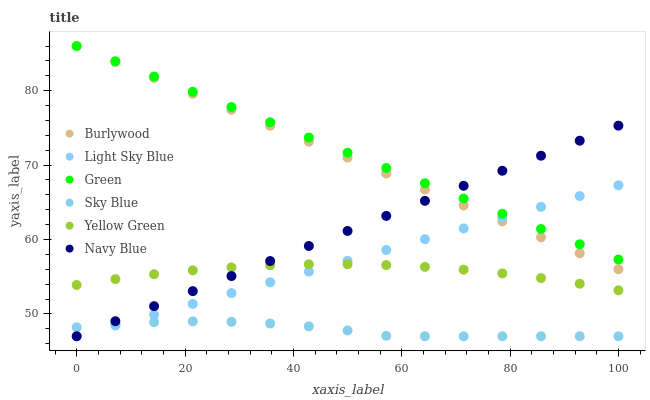Does Sky Blue have the minimum area under the curve?
Answer yes or no. Yes. Does Green have the maximum area under the curve?
Answer yes or no. Yes. Does Burlywood have the minimum area under the curve?
Answer yes or no. No. Does Burlywood have the maximum area under the curve?
Answer yes or no. No. Is Navy Blue the smoothest?
Answer yes or no. Yes. Is Sky Blue the roughest?
Answer yes or no. Yes. Is Burlywood the smoothest?
Answer yes or no. No. Is Burlywood the roughest?
Answer yes or no. No. Does Navy Blue have the lowest value?
Answer yes or no. Yes. Does Burlywood have the lowest value?
Answer yes or no. No. Does Green have the highest value?
Answer yes or no. Yes. Does Navy Blue have the highest value?
Answer yes or no. No. Is Sky Blue less than Green?
Answer yes or no. Yes. Is Burlywood greater than Sky Blue?
Answer yes or no. Yes. Does Light Sky Blue intersect Green?
Answer yes or no. Yes. Is Light Sky Blue less than Green?
Answer yes or no. No. Is Light Sky Blue greater than Green?
Answer yes or no. No. Does Sky Blue intersect Green?
Answer yes or no. No. 